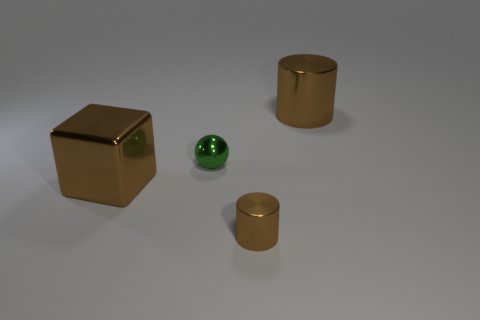There is a thing that is both to the right of the metal sphere and in front of the large brown cylinder; what material is it?
Provide a succinct answer. Metal. There is a green object that is made of the same material as the small cylinder; what is its shape?
Ensure brevity in your answer.  Sphere. Is there anything else that has the same color as the shiny sphere?
Ensure brevity in your answer.  No. Are there more brown cylinders that are behind the large metal block than tiny gray blocks?
Make the answer very short. Yes. What is the material of the large brown block?
Provide a short and direct response. Metal. How many balls have the same size as the metal block?
Provide a succinct answer. 0. Are there the same number of metallic cubes that are right of the big brown cylinder and green things behind the small green ball?
Keep it short and to the point. Yes. Do the tiny cylinder and the green sphere have the same material?
Your answer should be very brief. Yes. There is a object left of the green metallic thing; are there any small green metal spheres behind it?
Provide a short and direct response. Yes. Is there a big red shiny thing of the same shape as the tiny brown thing?
Your answer should be compact. No. 